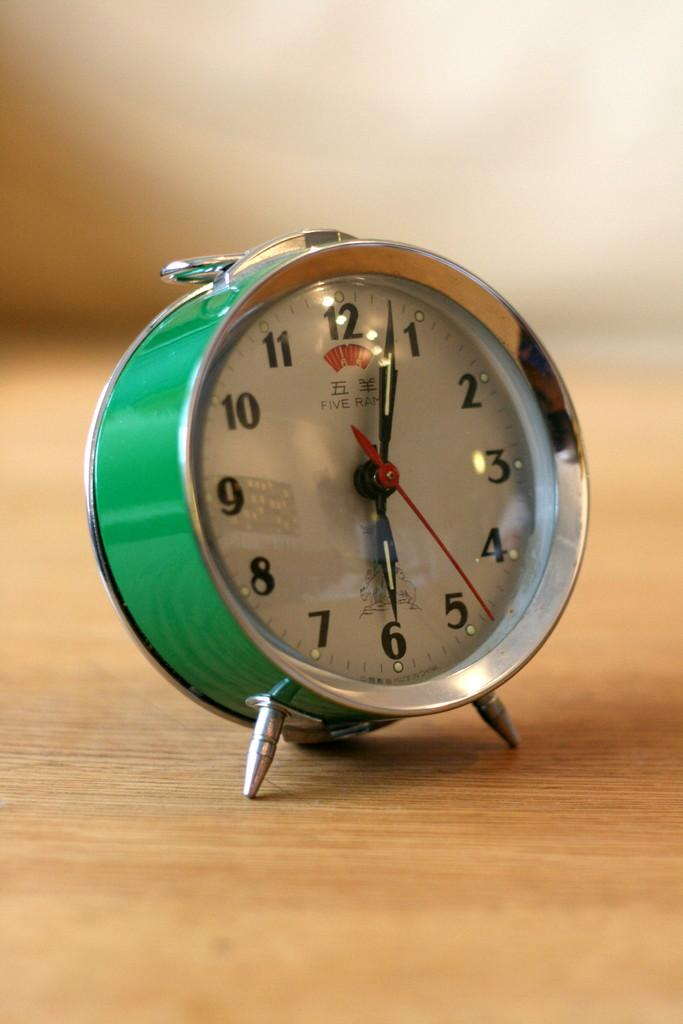<image>
Present a compact description of the photo's key features. An old-fashioned green alarm clock is showing 6:03. 